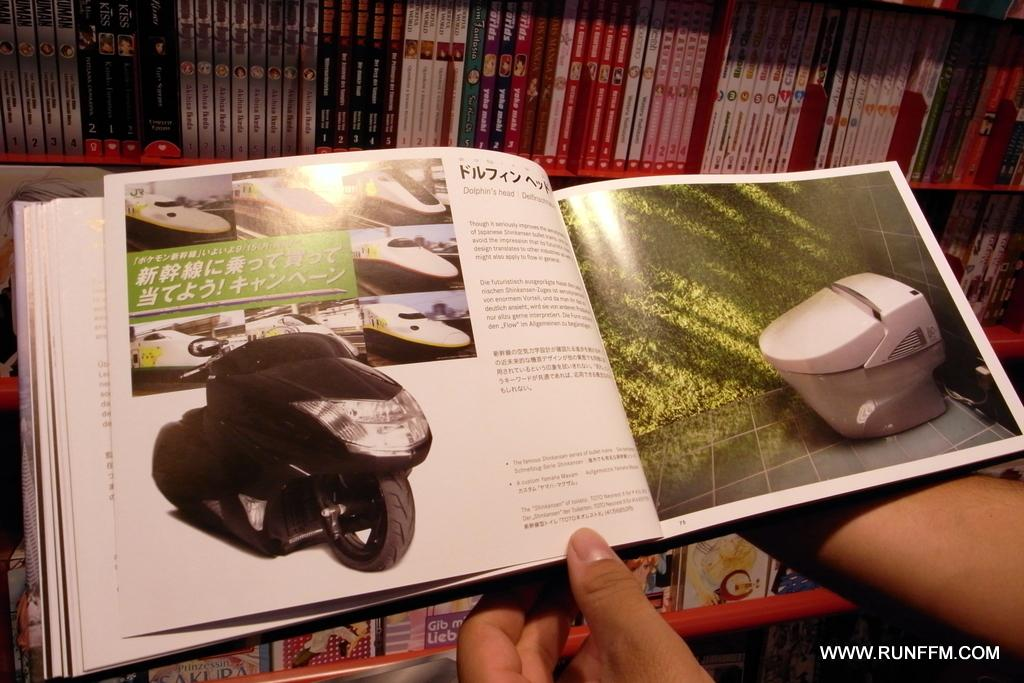What is the human in the image holding? The human is holding a book in the image. What can be seen on the pages of the book? There is text and pictures visible in the image. Where are the other books located in the image? There are books on shelves in the image. What is present at the bottom right corner of the image? There is text at the bottom right corner of the image. What day of the week is it in the image? The day of the week is not mentioned or depicted in the image. 